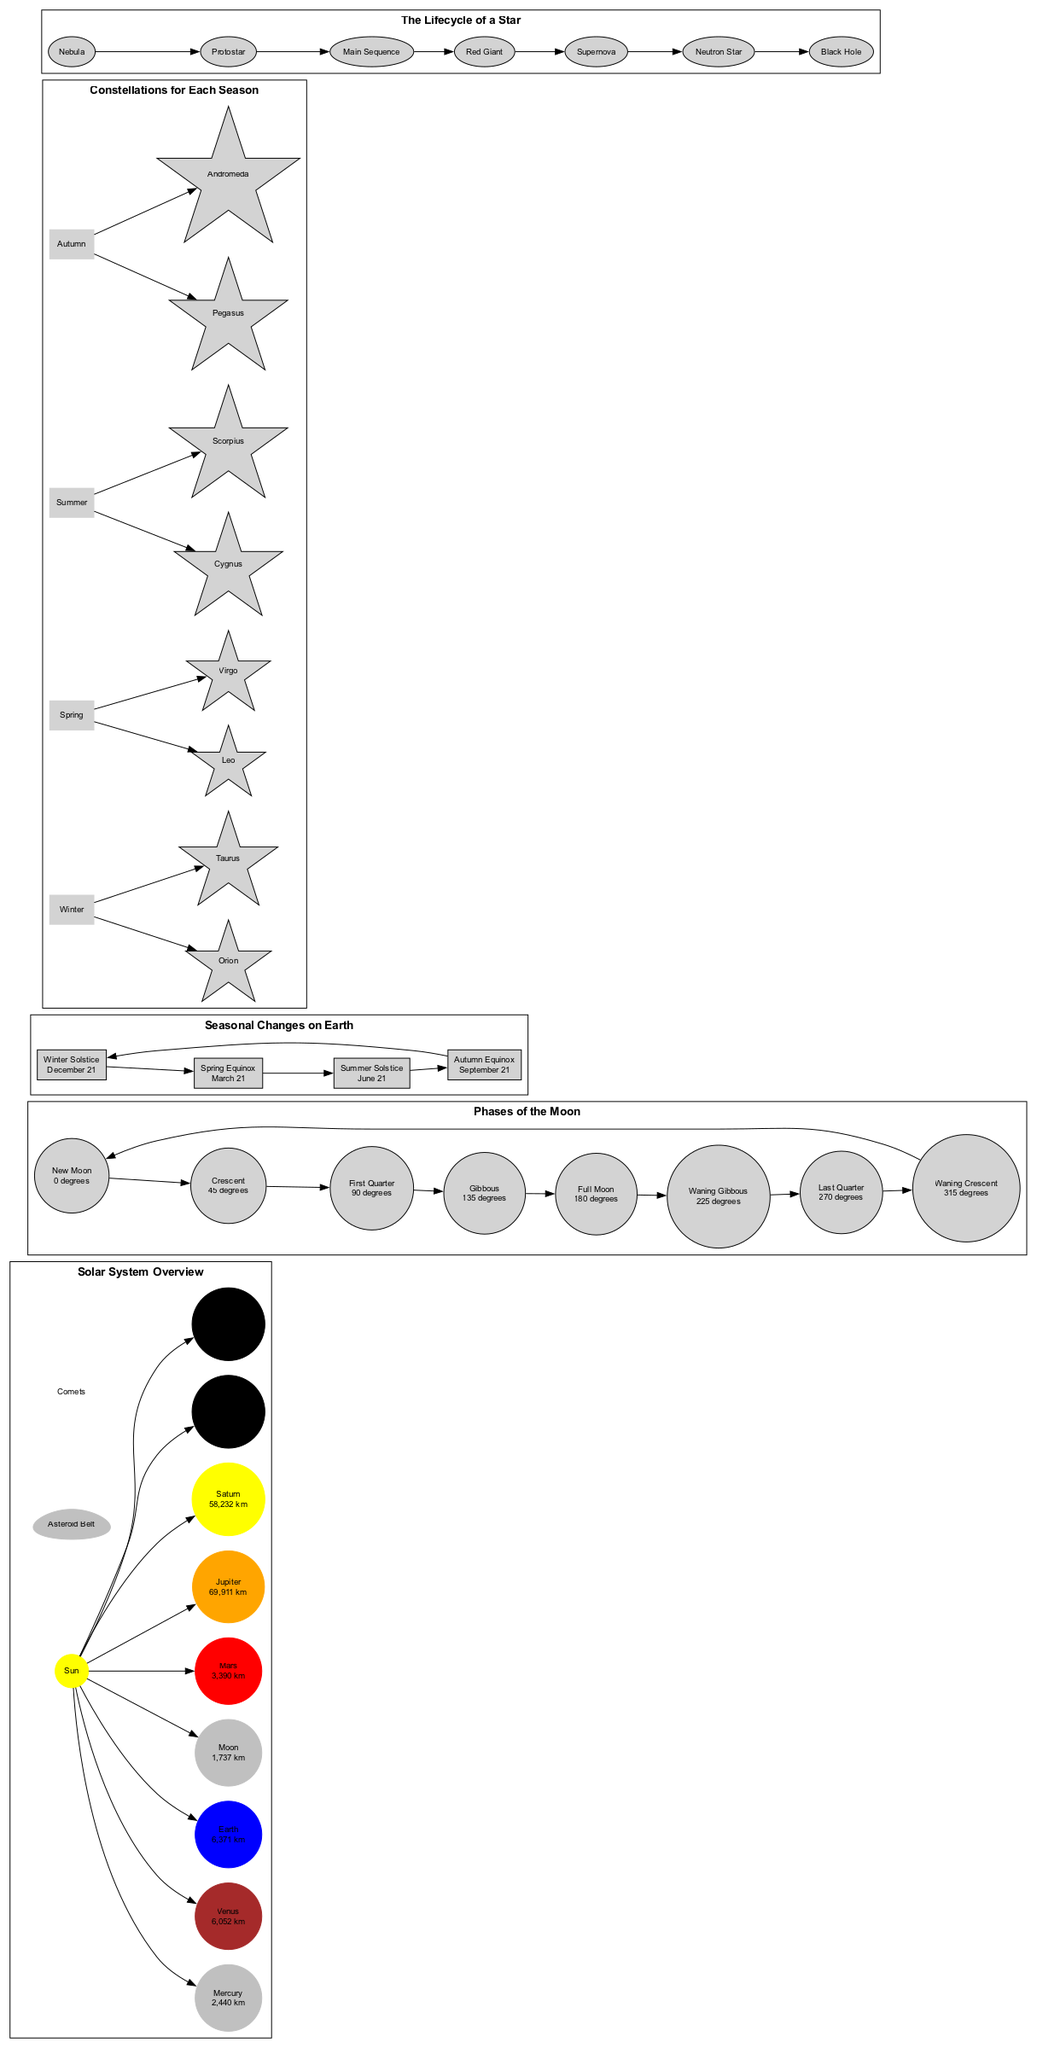What color is the Sun in the diagram? The diagram specifies the color associated with the Sun, which is listed as yellow.
Answer: yellow Which planet is closest to the Sun? The diagram identifies Mercury as the closest planet to the Sun.
Answer: Mercury What phase of the Moon is represented by 90 degrees? According to the diagram, the First Quarter phase corresponds to the position of 90 degrees.
Answer: First Quarter What date does the Summer Solstice occur? The diagram indicates that the Summer Solstice takes place on June 21.
Answer: June 21 How many main phases of the Moon are illustrated in the diagram? The diagram features a total of 8 phases of the Moon, including New Moon, Crescent, First Quarter, Gibbous, Full Moon, Waning Gibbous, Last Quarter, and Waning Crescent.
Answer: 8 Which constellation is associated with the winter season? The diagram lists Orion as a prominent constellation visible during the winter season.
Answer: Orion What occurs in the lifecycle of a star after the Main Sequence? The diagram shows that after the Main Sequence stage, a star becomes a Red Giant.
Answer: Red Giant Which celestial body is located between Mars and Jupiter? The diagram states that the Asteroid Belt is the region containing numerous rocky bodies situated between Mars and Jupiter.
Answer: Asteroid Belt What occurs on March 21 in relation to seasonal changes on Earth? The diagram concludes that March 21 is the date of the Spring Equinox, characterized by equal day and night.
Answer: Spring Equinox 